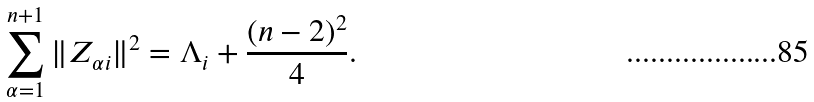<formula> <loc_0><loc_0><loc_500><loc_500>\sum _ { \alpha = 1 } ^ { n + 1 } \| Z _ { \alpha i } \| ^ { 2 } = \Lambda _ { i } + \frac { ( n - 2 ) ^ { 2 } } { 4 } .</formula> 